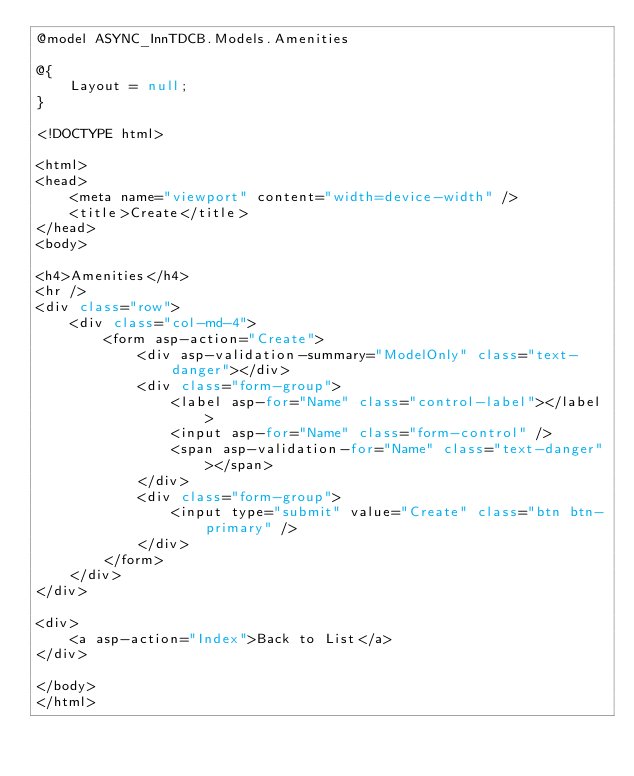Convert code to text. <code><loc_0><loc_0><loc_500><loc_500><_C#_>@model ASYNC_InnTDCB.Models.Amenities

@{
    Layout = null;
}

<!DOCTYPE html>

<html>
<head>
    <meta name="viewport" content="width=device-width" />
    <title>Create</title>
</head>
<body>

<h4>Amenities</h4>
<hr />
<div class="row">
    <div class="col-md-4">
        <form asp-action="Create">
            <div asp-validation-summary="ModelOnly" class="text-danger"></div>
            <div class="form-group">
                <label asp-for="Name" class="control-label"></label>
                <input asp-for="Name" class="form-control" />
                <span asp-validation-for="Name" class="text-danger"></span>
            </div>
            <div class="form-group">
                <input type="submit" value="Create" class="btn btn-primary" />
            </div>
        </form>
    </div>
</div>

<div>
    <a asp-action="Index">Back to List</a>
</div>

</body>
</html>
</code> 